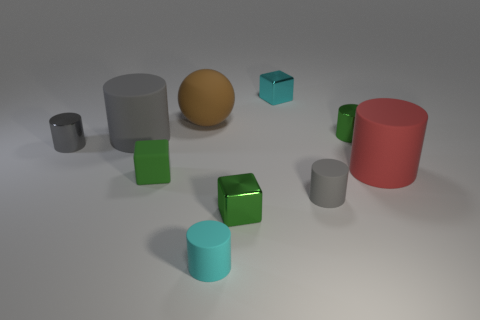Subtract all gray cylinders. How many were subtracted if there are1gray cylinders left? 2 Subtract all yellow cubes. How many gray cylinders are left? 3 Subtract all big matte cylinders. How many cylinders are left? 4 Subtract all green cylinders. How many cylinders are left? 5 Subtract 1 cylinders. How many cylinders are left? 5 Subtract all red cylinders. Subtract all purple balls. How many cylinders are left? 5 Subtract all cylinders. How many objects are left? 4 Subtract all big brown blocks. Subtract all tiny metal cubes. How many objects are left? 8 Add 6 small green rubber objects. How many small green rubber objects are left? 7 Add 5 gray cylinders. How many gray cylinders exist? 8 